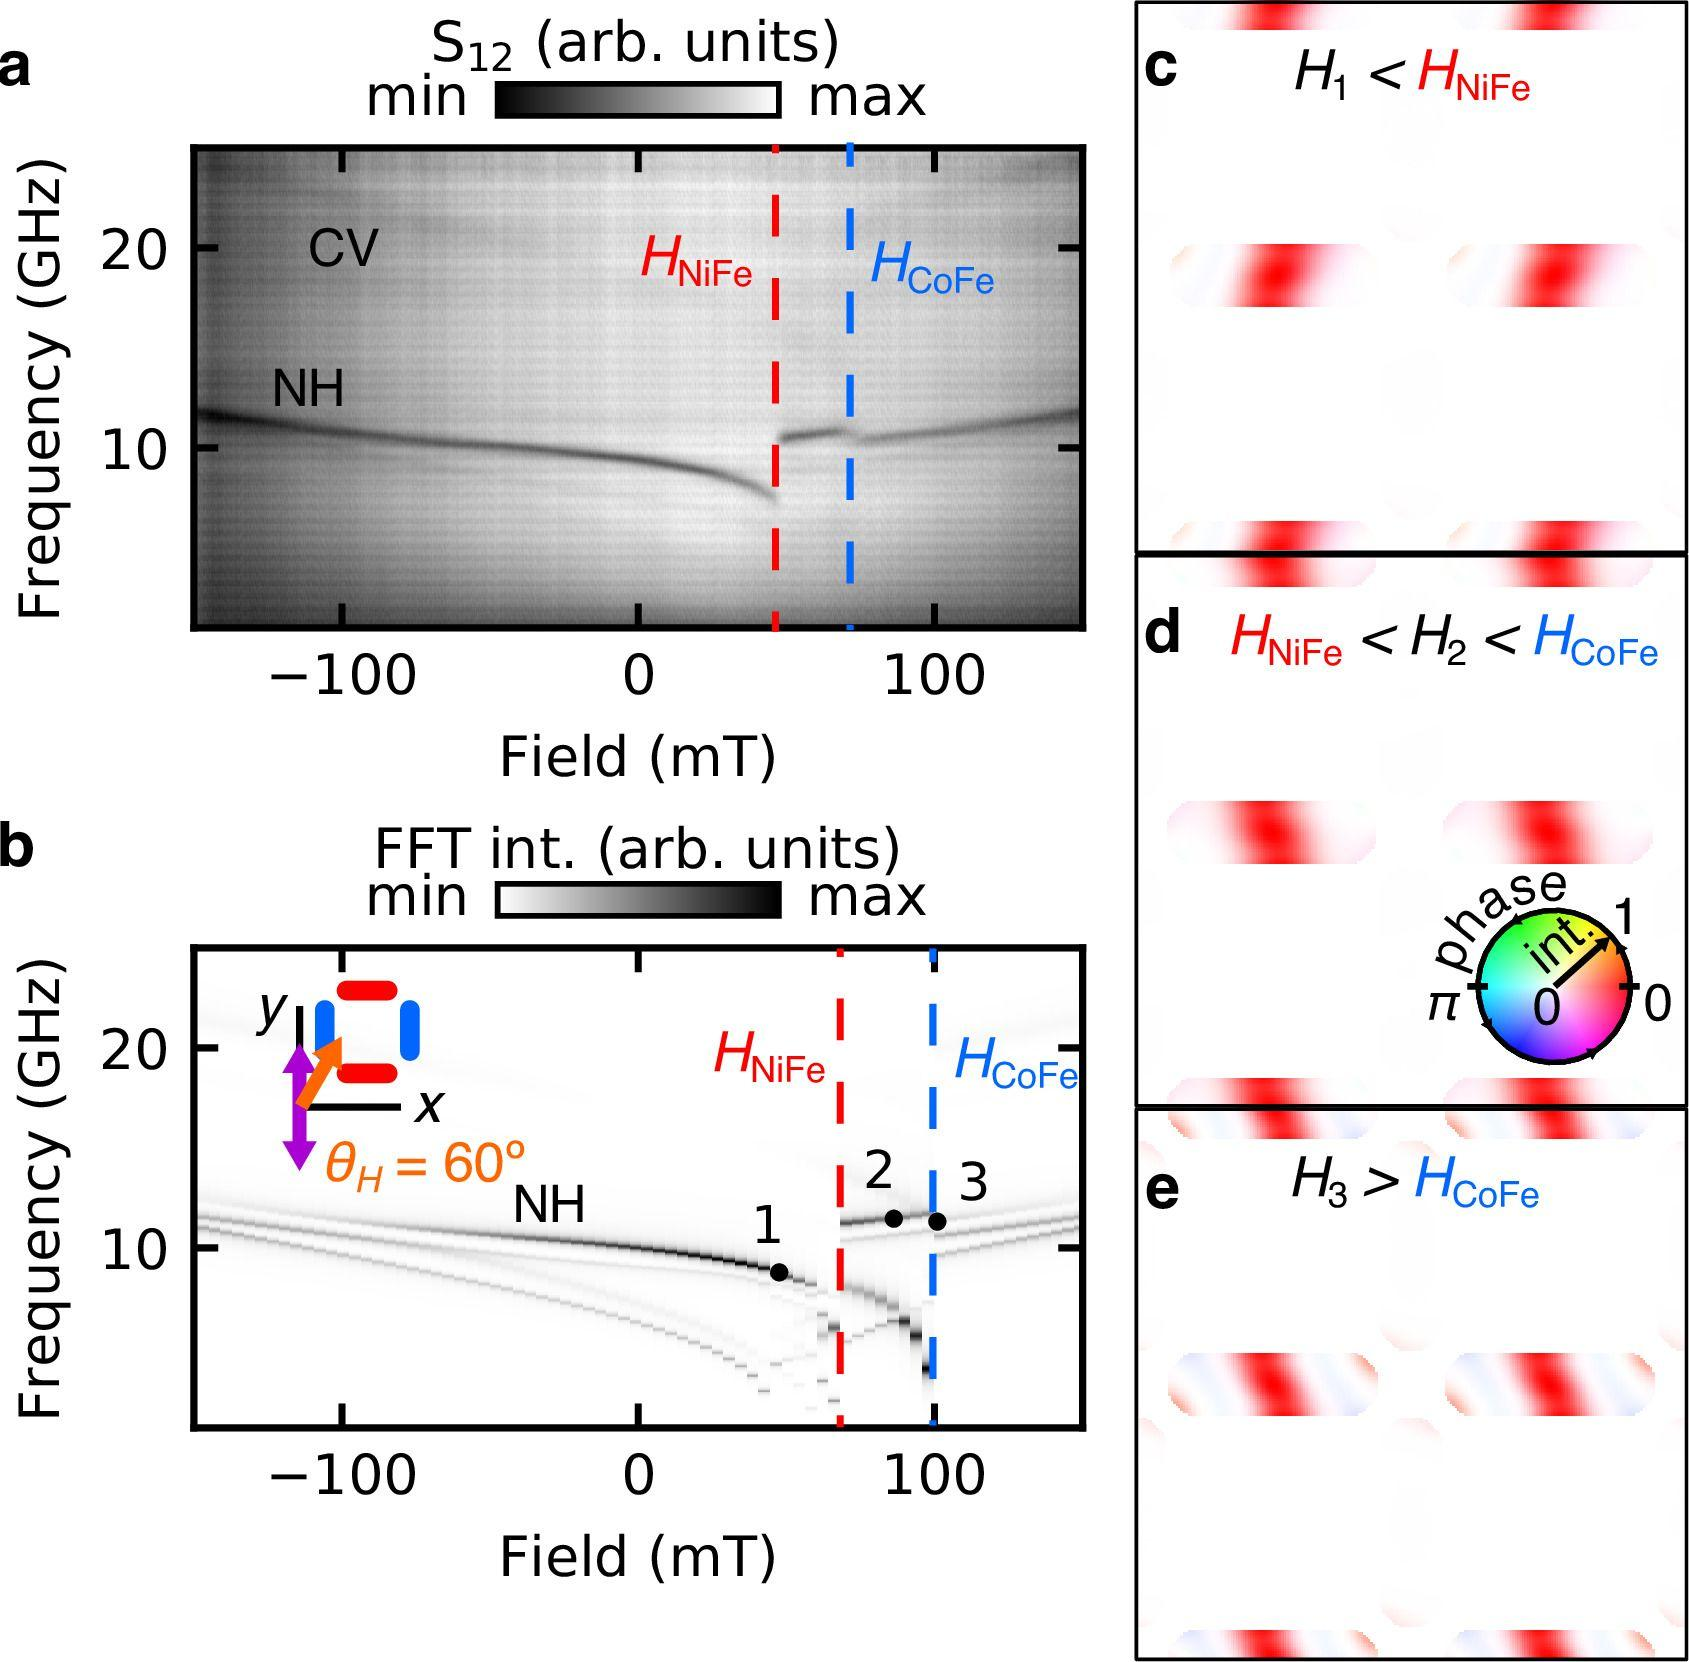What potential applications or implications might this data about magnetic field strengths have in practical scenarios? The data depicted in these panels are critical in fields like materials science and engineering, especially in the design and testing of magnetic materials and components. Understanding the behavior of different magnetic fields relative to specific materials like NiFe and CoFe can help in tailoring magnetic properties to suit particular applications, such as in MRI machines, data storage devices, and electromagnetic shielding. The precise manipulations and evaluations can lead to innovations in technology where enhanced magnetic properties are crucial. 